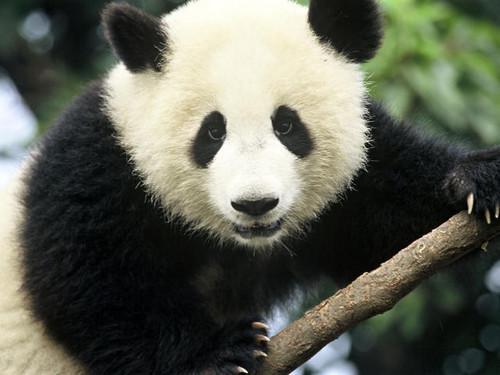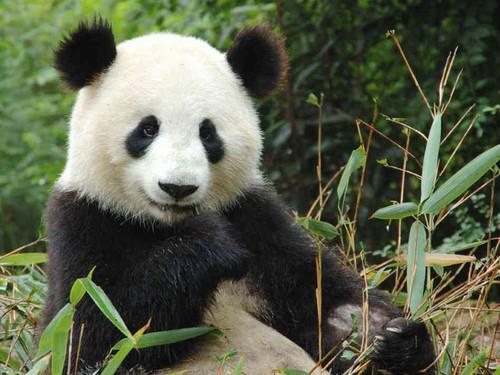The first image is the image on the left, the second image is the image on the right. For the images displayed, is the sentence "The right image contains two pandas in close contact." factually correct? Answer yes or no. No. The first image is the image on the left, the second image is the image on the right. Evaluate the accuracy of this statement regarding the images: "There is at least one pair of pandas hugging.". Is it true? Answer yes or no. No. The first image is the image on the left, the second image is the image on the right. Assess this claim about the two images: "The panda on the left image is on a tree branch.". Correct or not? Answer yes or no. Yes. 